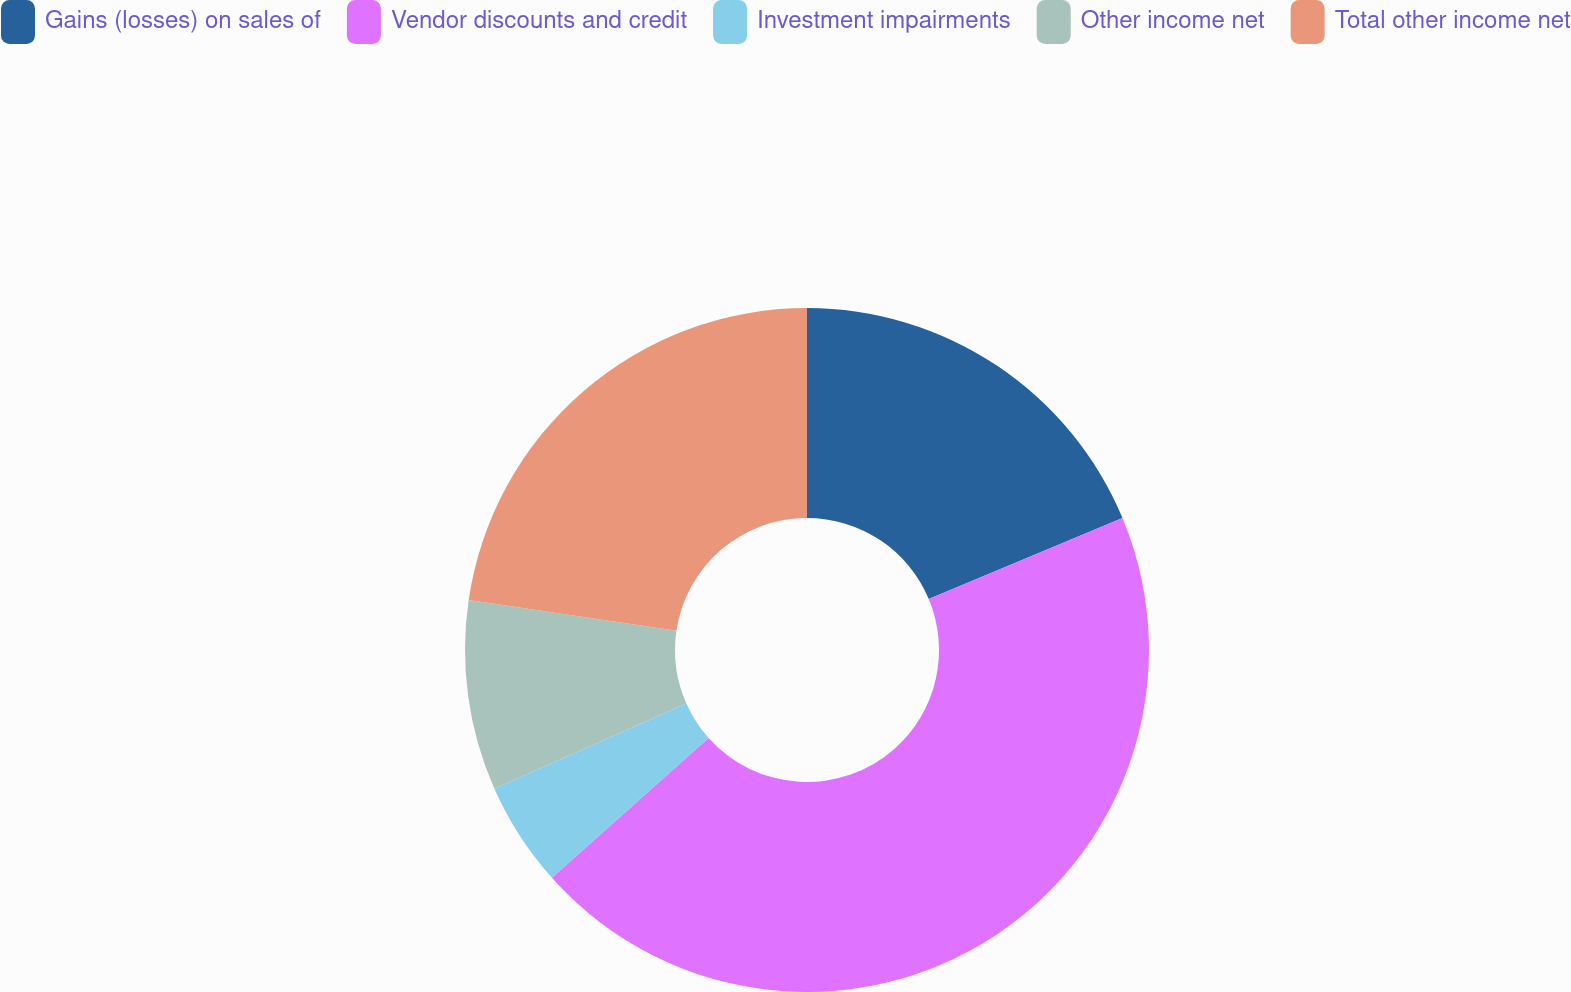Convert chart to OTSL. <chart><loc_0><loc_0><loc_500><loc_500><pie_chart><fcel>Gains (losses) on sales of<fcel>Vendor discounts and credit<fcel>Investment impairments<fcel>Other income net<fcel>Total other income net<nl><fcel>18.69%<fcel>44.71%<fcel>4.95%<fcel>8.98%<fcel>22.67%<nl></chart> 